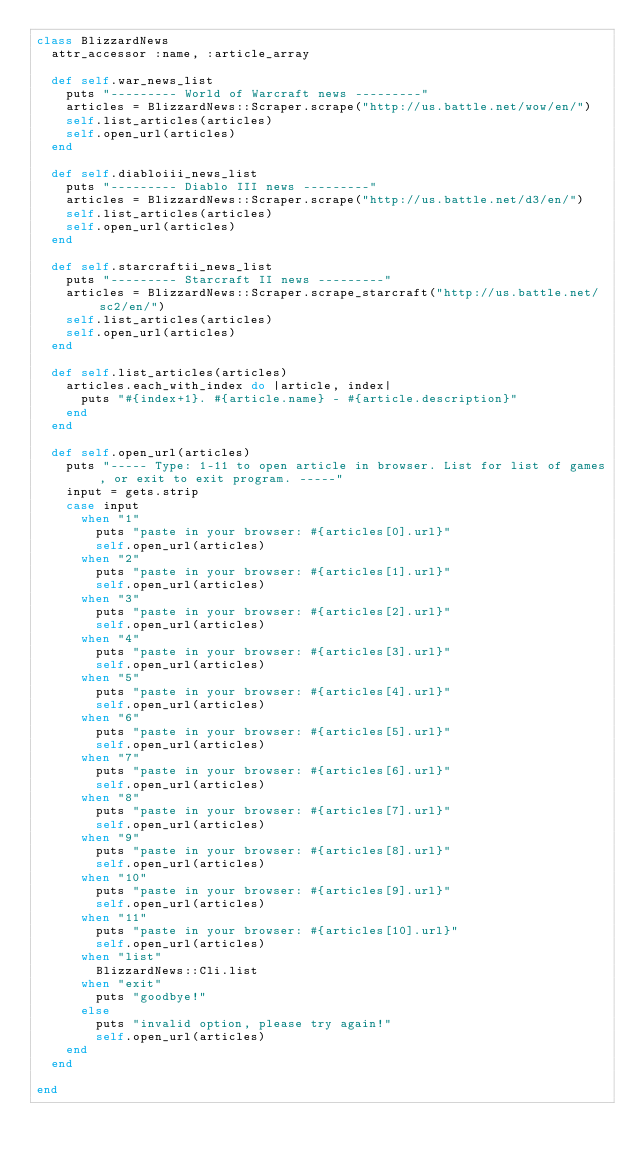Convert code to text. <code><loc_0><loc_0><loc_500><loc_500><_Ruby_>class BlizzardNews
  attr_accessor :name, :article_array

  def self.war_news_list
    puts "--------- World of Warcraft news ---------"
    articles = BlizzardNews::Scraper.scrape("http://us.battle.net/wow/en/")
    self.list_articles(articles)
    self.open_url(articles)
  end

  def self.diabloiii_news_list
    puts "--------- Diablo III news ---------"
    articles = BlizzardNews::Scraper.scrape("http://us.battle.net/d3/en/")
    self.list_articles(articles)
    self.open_url(articles)
  end

  def self.starcraftii_news_list
    puts "--------- Starcraft II news ---------"
    articles = BlizzardNews::Scraper.scrape_starcraft("http://us.battle.net/sc2/en/")
    self.list_articles(articles)
    self.open_url(articles)
  end

  def self.list_articles(articles)
    articles.each_with_index do |article, index|
      puts "#{index+1}. #{article.name} - #{article.description}"
    end
  end

  def self.open_url(articles)
    puts "----- Type: 1-11 to open article in browser. List for list of games, or exit to exit program. -----"
    input = gets.strip
    case input
      when "1"
        puts "paste in your browser: #{articles[0].url}"
        self.open_url(articles)
      when "2"
        puts "paste in your browser: #{articles[1].url}"
        self.open_url(articles)
      when "3"
        puts "paste in your browser: #{articles[2].url}"
        self.open_url(articles)
      when "4"
        puts "paste in your browser: #{articles[3].url}"
        self.open_url(articles)
      when "5"
        puts "paste in your browser: #{articles[4].url}"
        self.open_url(articles)
      when "6"
        puts "paste in your browser: #{articles[5].url}"
        self.open_url(articles)
      when "7"
        puts "paste in your browser: #{articles[6].url}"
        self.open_url(articles)
      when "8"
        puts "paste in your browser: #{articles[7].url}"
        self.open_url(articles)
      when "9"
        puts "paste in your browser: #{articles[8].url}"
        self.open_url(articles)
      when "10"
        puts "paste in your browser: #{articles[9].url}"
        self.open_url(articles)
      when "11"
        puts "paste in your browser: #{articles[10].url}"
        self.open_url(articles)
      when "list"
        BlizzardNews::Cli.list
      when "exit"
        puts "goodbye!"
      else
        puts "invalid option, please try again!"
        self.open_url(articles)
    end
  end

end</code> 